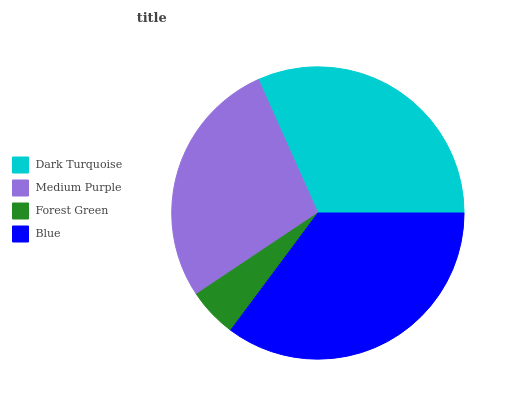Is Forest Green the minimum?
Answer yes or no. Yes. Is Blue the maximum?
Answer yes or no. Yes. Is Medium Purple the minimum?
Answer yes or no. No. Is Medium Purple the maximum?
Answer yes or no. No. Is Dark Turquoise greater than Medium Purple?
Answer yes or no. Yes. Is Medium Purple less than Dark Turquoise?
Answer yes or no. Yes. Is Medium Purple greater than Dark Turquoise?
Answer yes or no. No. Is Dark Turquoise less than Medium Purple?
Answer yes or no. No. Is Dark Turquoise the high median?
Answer yes or no. Yes. Is Medium Purple the low median?
Answer yes or no. Yes. Is Blue the high median?
Answer yes or no. No. Is Forest Green the low median?
Answer yes or no. No. 